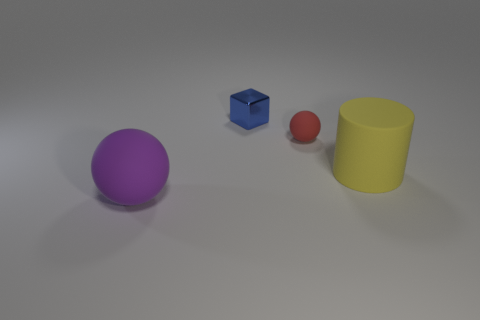Add 1 big yellow matte things. How many objects exist? 5 Subtract 1 spheres. How many spheres are left? 1 Add 4 small blue metal things. How many small blue metal things exist? 5 Subtract 0 brown cylinders. How many objects are left? 4 Subtract all blocks. How many objects are left? 3 Subtract all green cylinders. Subtract all purple balls. How many cylinders are left? 1 Subtract all green blocks. How many blue cylinders are left? 0 Subtract all yellow things. Subtract all tiny blue metallic cubes. How many objects are left? 2 Add 2 cylinders. How many cylinders are left? 3 